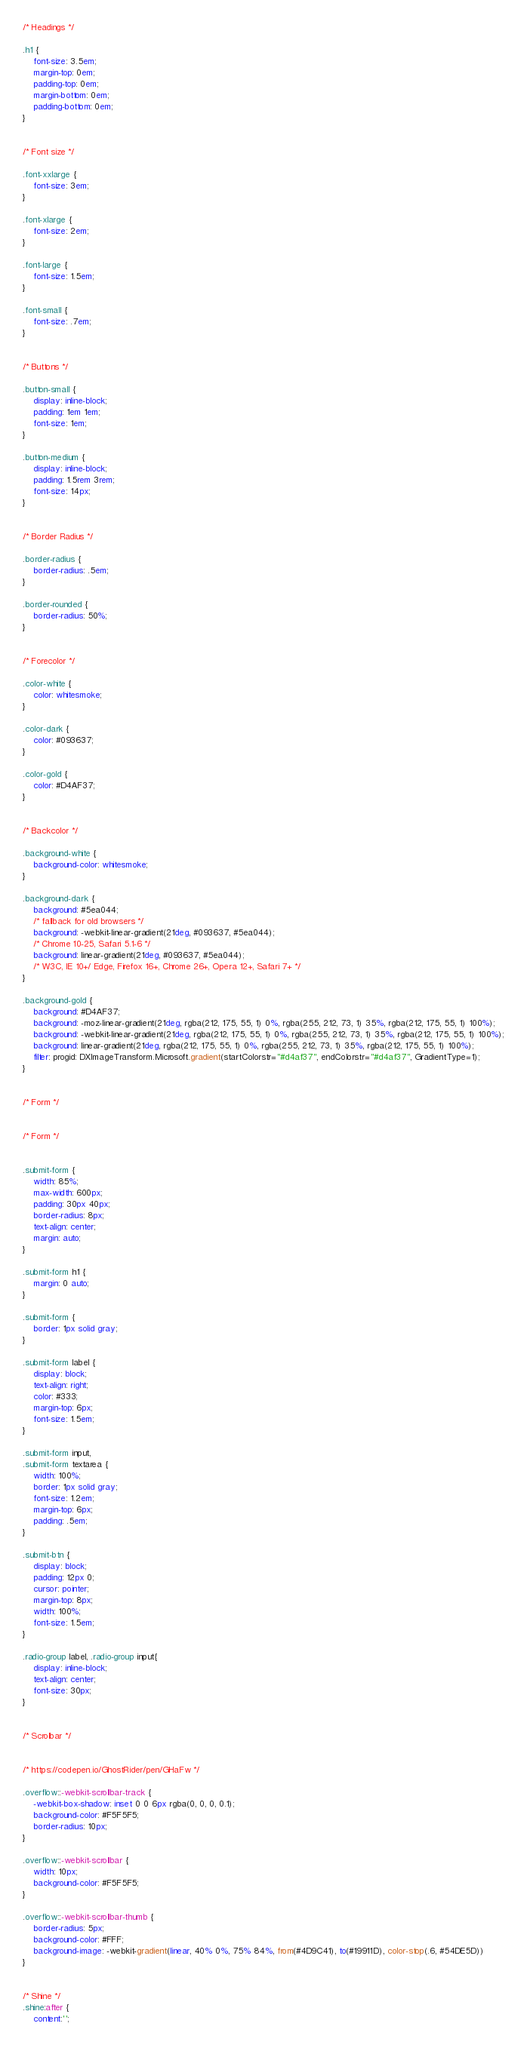Convert code to text. <code><loc_0><loc_0><loc_500><loc_500><_CSS_>/* Headings */

.h1 {
    font-size: 3.5em;
    margin-top: 0em;
    padding-top: 0em;
    margin-bottom: 0em;
    padding-bottom: 0em;
}


/* Font size */

.font-xxlarge {
    font-size: 3em;
}

.font-xlarge {
    font-size: 2em;
}

.font-large {
    font-size: 1.5em;
}

.font-small {
    font-size: .7em;
}


/* Buttons */

.button-small {
    display: inline-block;
    padding: 1em 1em;
    font-size: 1em;
}

.button-medium {
    display: inline-block;
    padding: 1.5rem 3rem;
    font-size: 14px;
}


/* Border Radius */

.border-radius {
    border-radius: .5em;
}

.border-rounded {
    border-radius: 50%;
}


/* Forecolor */

.color-white {
    color: whitesmoke;
}

.color-dark {
    color: #093637;
}

.color-gold {
    color: #D4AF37;
}


/* Backcolor */

.background-white {
    background-color: whitesmoke;
}

.background-dark {
    background: #5ea044;
    /* fallback for old browsers */
    background: -webkit-linear-gradient(21deg, #093637, #5ea044);
    /* Chrome 10-25, Safari 5.1-6 */
    background: linear-gradient(21deg, #093637, #5ea044);
    /* W3C, IE 10+/ Edge, Firefox 16+, Chrome 26+, Opera 12+, Safari 7+ */
}

.background-gold {
    background: #D4AF37;
    background: -moz-linear-gradient(21deg, rgba(212, 175, 55, 1) 0%, rgba(255, 212, 73, 1) 35%, rgba(212, 175, 55, 1) 100%);
    background: -webkit-linear-gradient(21deg, rgba(212, 175, 55, 1) 0%, rgba(255, 212, 73, 1) 35%, rgba(212, 175, 55, 1) 100%);
    background: linear-gradient(21deg, rgba(212, 175, 55, 1) 0%, rgba(255, 212, 73, 1) 35%, rgba(212, 175, 55, 1) 100%);
    filter: progid: DXImageTransform.Microsoft.gradient(startColorstr="#d4af37", endColorstr="#d4af37", GradientType=1);
}


/* Form */


/* Form */


.submit-form {
    width: 85%;
    max-width: 600px;
    padding: 30px 40px;
    border-radius: 8px;
    text-align: center;
    margin: auto;
}

.submit-form h1 {
    margin: 0 auto;
}

.submit-form {
    border: 1px solid gray;
}

.submit-form label {
    display: block;
    text-align: right;
    color: #333;
    margin-top: 6px;
    font-size: 1.5em;
}

.submit-form input,
.submit-form textarea {
    width: 100%;
    border: 1px solid gray;
    font-size: 1.2em;
    margin-top: 6px;
    padding: .5em;
}

.submit-btn {
    display: block;
    padding: 12px 0;
    cursor: pointer;
    margin-top: 8px;
    width: 100%;
    font-size: 1.5em;
}

.radio-group label, .radio-group input{
    display: inline-block;
    text-align: center;
    font-size: 30px;
}


/* Scrolbar */


/* https://codepen.io/GhostRider/pen/GHaFw */

.overflow::-webkit-scrollbar-track {
    -webkit-box-shadow: inset 0 0 6px rgba(0, 0, 0, 0.1);
    background-color: #F5F5F5;
    border-radius: 10px;
}

.overflow::-webkit-scrollbar {
    width: 10px;
    background-color: #F5F5F5;
}

.overflow::-webkit-scrollbar-thumb {
    border-radius: 5px;
    background-color: #FFF;
    background-image: -webkit-gradient(linear, 40% 0%, 75% 84%, from(#4D9C41), to(#19911D), color-stop(.6, #54DE5D))
}


/* Shine */
.shine:after {
	content:'';</code> 